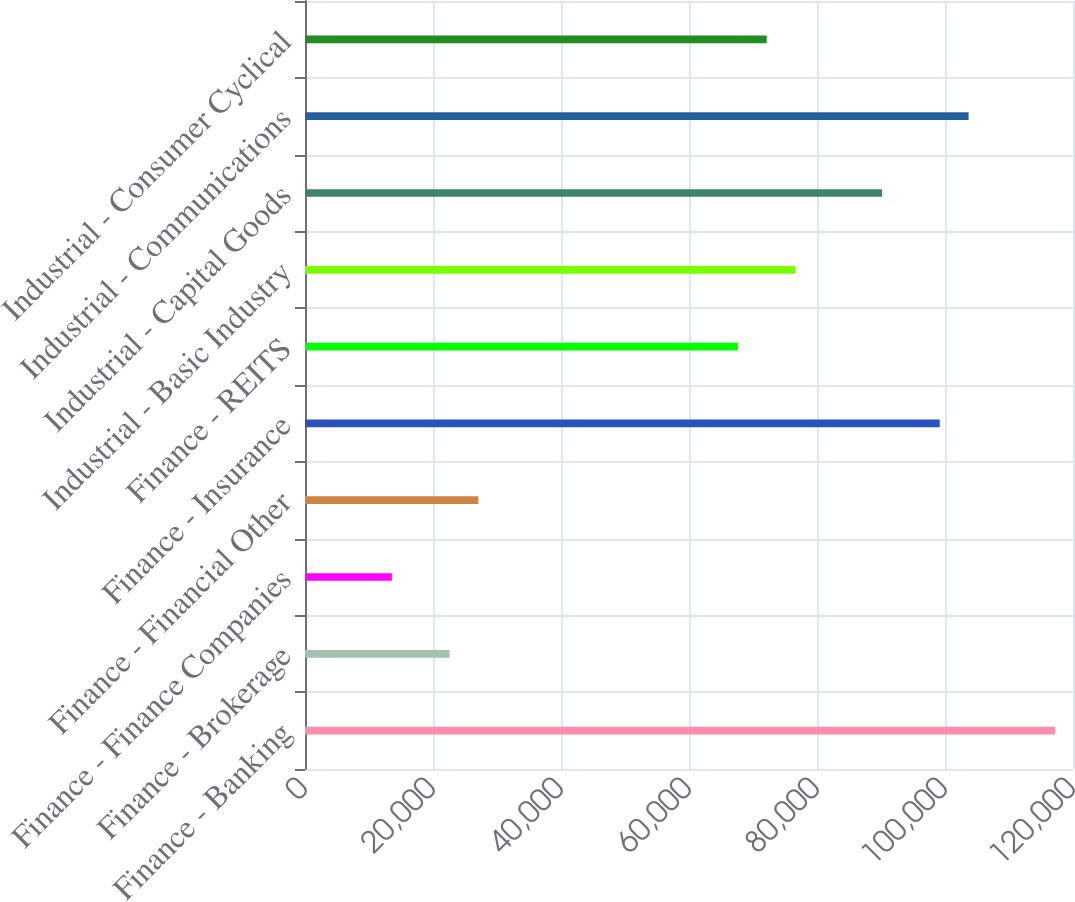<chart> <loc_0><loc_0><loc_500><loc_500><bar_chart><fcel>Finance - Banking<fcel>Finance - Brokerage<fcel>Finance - Finance Companies<fcel>Finance - Financial Other<fcel>Finance - Insurance<fcel>Finance - REITS<fcel>Industrial - Basic Industry<fcel>Industrial - Capital Goods<fcel>Industrial - Communications<fcel>Industrial - Consumer Cyclical<nl><fcel>117208<fcel>22581.8<fcel>13569.9<fcel>27087.8<fcel>99183.7<fcel>67641.8<fcel>76653.7<fcel>90171.7<fcel>103690<fcel>72147.7<nl></chart> 